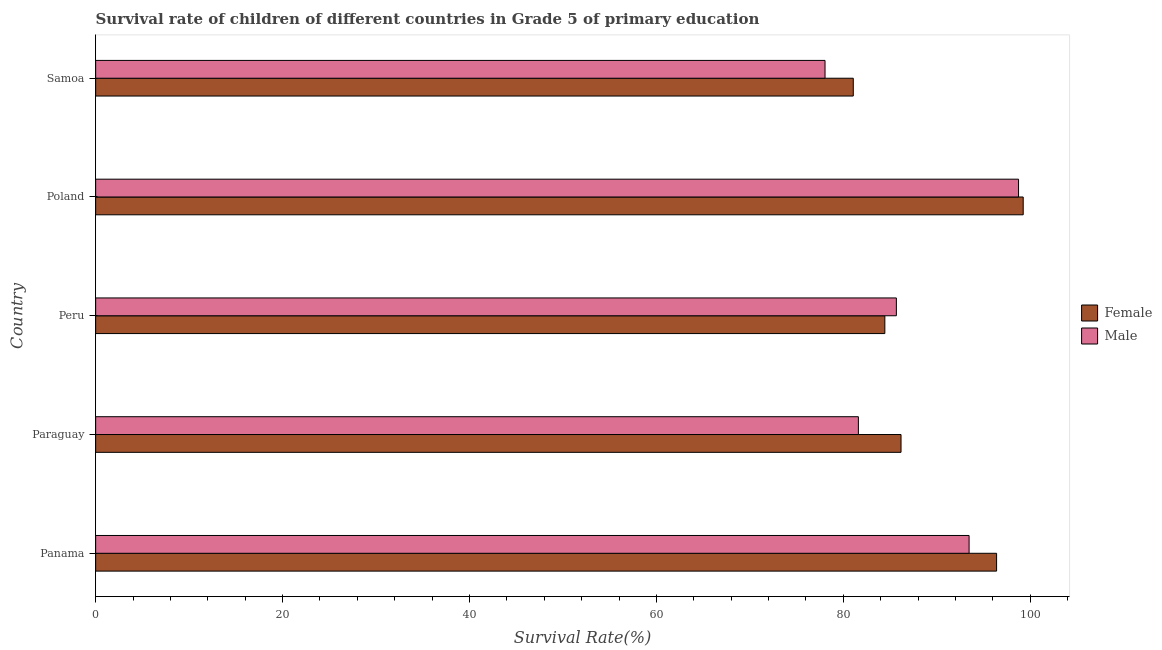How many groups of bars are there?
Ensure brevity in your answer.  5. Are the number of bars on each tick of the Y-axis equal?
Provide a short and direct response. Yes. What is the label of the 1st group of bars from the top?
Your answer should be compact. Samoa. In how many cases, is the number of bars for a given country not equal to the number of legend labels?
Your answer should be compact. 0. What is the survival rate of female students in primary education in Panama?
Keep it short and to the point. 96.4. Across all countries, what is the maximum survival rate of male students in primary education?
Your answer should be compact. 98.74. Across all countries, what is the minimum survival rate of female students in primary education?
Keep it short and to the point. 81.06. In which country was the survival rate of male students in primary education minimum?
Your response must be concise. Samoa. What is the total survival rate of female students in primary education in the graph?
Your answer should be compact. 447.31. What is the difference between the survival rate of female students in primary education in Paraguay and that in Peru?
Give a very brief answer. 1.73. What is the difference between the survival rate of female students in primary education in Paraguay and the survival rate of male students in primary education in Poland?
Your answer should be very brief. -12.57. What is the average survival rate of male students in primary education per country?
Provide a succinct answer. 87.5. What is the difference between the survival rate of male students in primary education and survival rate of female students in primary education in Paraguay?
Your answer should be compact. -4.56. In how many countries, is the survival rate of female students in primary education greater than 16 %?
Provide a short and direct response. 5. What is the ratio of the survival rate of female students in primary education in Peru to that in Poland?
Your response must be concise. 0.85. What is the difference between the highest and the second highest survival rate of male students in primary education?
Provide a short and direct response. 5.29. What is the difference between the highest and the lowest survival rate of male students in primary education?
Keep it short and to the point. 20.7. In how many countries, is the survival rate of female students in primary education greater than the average survival rate of female students in primary education taken over all countries?
Offer a terse response. 2. Is the sum of the survival rate of male students in primary education in Paraguay and Peru greater than the maximum survival rate of female students in primary education across all countries?
Offer a very short reply. Yes. What does the 2nd bar from the bottom in Panama represents?
Ensure brevity in your answer.  Male. How many bars are there?
Keep it short and to the point. 10. Are all the bars in the graph horizontal?
Make the answer very short. Yes. What is the difference between two consecutive major ticks on the X-axis?
Your response must be concise. 20. Does the graph contain any zero values?
Your answer should be compact. No. Does the graph contain grids?
Make the answer very short. No. How are the legend labels stacked?
Offer a terse response. Vertical. What is the title of the graph?
Your answer should be compact. Survival rate of children of different countries in Grade 5 of primary education. What is the label or title of the X-axis?
Offer a very short reply. Survival Rate(%). What is the Survival Rate(%) in Female in Panama?
Make the answer very short. 96.4. What is the Survival Rate(%) in Male in Panama?
Provide a short and direct response. 93.45. What is the Survival Rate(%) of Female in Paraguay?
Give a very brief answer. 86.17. What is the Survival Rate(%) of Male in Paraguay?
Provide a short and direct response. 81.61. What is the Survival Rate(%) in Female in Peru?
Give a very brief answer. 84.44. What is the Survival Rate(%) in Male in Peru?
Give a very brief answer. 85.67. What is the Survival Rate(%) of Female in Poland?
Your answer should be compact. 99.24. What is the Survival Rate(%) of Male in Poland?
Your answer should be compact. 98.74. What is the Survival Rate(%) in Female in Samoa?
Make the answer very short. 81.06. What is the Survival Rate(%) of Male in Samoa?
Provide a succinct answer. 78.04. Across all countries, what is the maximum Survival Rate(%) in Female?
Make the answer very short. 99.24. Across all countries, what is the maximum Survival Rate(%) of Male?
Your answer should be very brief. 98.74. Across all countries, what is the minimum Survival Rate(%) in Female?
Give a very brief answer. 81.06. Across all countries, what is the minimum Survival Rate(%) in Male?
Provide a succinct answer. 78.04. What is the total Survival Rate(%) in Female in the graph?
Provide a short and direct response. 447.31. What is the total Survival Rate(%) in Male in the graph?
Provide a succinct answer. 437.52. What is the difference between the Survival Rate(%) of Female in Panama and that in Paraguay?
Make the answer very short. 10.23. What is the difference between the Survival Rate(%) in Male in Panama and that in Paraguay?
Provide a succinct answer. 11.84. What is the difference between the Survival Rate(%) in Female in Panama and that in Peru?
Ensure brevity in your answer.  11.96. What is the difference between the Survival Rate(%) of Male in Panama and that in Peru?
Your answer should be compact. 7.78. What is the difference between the Survival Rate(%) in Female in Panama and that in Poland?
Offer a very short reply. -2.85. What is the difference between the Survival Rate(%) in Male in Panama and that in Poland?
Your response must be concise. -5.29. What is the difference between the Survival Rate(%) of Female in Panama and that in Samoa?
Ensure brevity in your answer.  15.33. What is the difference between the Survival Rate(%) of Male in Panama and that in Samoa?
Ensure brevity in your answer.  15.41. What is the difference between the Survival Rate(%) of Female in Paraguay and that in Peru?
Provide a succinct answer. 1.73. What is the difference between the Survival Rate(%) in Male in Paraguay and that in Peru?
Your answer should be very brief. -4.06. What is the difference between the Survival Rate(%) in Female in Paraguay and that in Poland?
Keep it short and to the point. -13.07. What is the difference between the Survival Rate(%) of Male in Paraguay and that in Poland?
Provide a succinct answer. -17.14. What is the difference between the Survival Rate(%) of Female in Paraguay and that in Samoa?
Your answer should be compact. 5.11. What is the difference between the Survival Rate(%) in Male in Paraguay and that in Samoa?
Make the answer very short. 3.57. What is the difference between the Survival Rate(%) in Female in Peru and that in Poland?
Ensure brevity in your answer.  -14.8. What is the difference between the Survival Rate(%) in Male in Peru and that in Poland?
Keep it short and to the point. -13.07. What is the difference between the Survival Rate(%) of Female in Peru and that in Samoa?
Your response must be concise. 3.38. What is the difference between the Survival Rate(%) in Male in Peru and that in Samoa?
Your answer should be very brief. 7.63. What is the difference between the Survival Rate(%) of Female in Poland and that in Samoa?
Your answer should be compact. 18.18. What is the difference between the Survival Rate(%) in Male in Poland and that in Samoa?
Ensure brevity in your answer.  20.7. What is the difference between the Survival Rate(%) in Female in Panama and the Survival Rate(%) in Male in Paraguay?
Provide a succinct answer. 14.79. What is the difference between the Survival Rate(%) in Female in Panama and the Survival Rate(%) in Male in Peru?
Your answer should be very brief. 10.72. What is the difference between the Survival Rate(%) of Female in Panama and the Survival Rate(%) of Male in Poland?
Provide a short and direct response. -2.35. What is the difference between the Survival Rate(%) of Female in Panama and the Survival Rate(%) of Male in Samoa?
Offer a terse response. 18.36. What is the difference between the Survival Rate(%) in Female in Paraguay and the Survival Rate(%) in Male in Peru?
Give a very brief answer. 0.5. What is the difference between the Survival Rate(%) of Female in Paraguay and the Survival Rate(%) of Male in Poland?
Ensure brevity in your answer.  -12.57. What is the difference between the Survival Rate(%) in Female in Paraguay and the Survival Rate(%) in Male in Samoa?
Provide a succinct answer. 8.13. What is the difference between the Survival Rate(%) in Female in Peru and the Survival Rate(%) in Male in Poland?
Offer a very short reply. -14.31. What is the difference between the Survival Rate(%) of Female in Peru and the Survival Rate(%) of Male in Samoa?
Provide a short and direct response. 6.4. What is the difference between the Survival Rate(%) in Female in Poland and the Survival Rate(%) in Male in Samoa?
Your response must be concise. 21.2. What is the average Survival Rate(%) in Female per country?
Ensure brevity in your answer.  89.46. What is the average Survival Rate(%) in Male per country?
Give a very brief answer. 87.5. What is the difference between the Survival Rate(%) in Female and Survival Rate(%) in Male in Panama?
Your response must be concise. 2.94. What is the difference between the Survival Rate(%) in Female and Survival Rate(%) in Male in Paraguay?
Make the answer very short. 4.56. What is the difference between the Survival Rate(%) in Female and Survival Rate(%) in Male in Peru?
Give a very brief answer. -1.23. What is the difference between the Survival Rate(%) in Female and Survival Rate(%) in Male in Poland?
Your response must be concise. 0.5. What is the difference between the Survival Rate(%) in Female and Survival Rate(%) in Male in Samoa?
Keep it short and to the point. 3.02. What is the ratio of the Survival Rate(%) in Female in Panama to that in Paraguay?
Keep it short and to the point. 1.12. What is the ratio of the Survival Rate(%) in Male in Panama to that in Paraguay?
Keep it short and to the point. 1.15. What is the ratio of the Survival Rate(%) in Female in Panama to that in Peru?
Offer a terse response. 1.14. What is the ratio of the Survival Rate(%) in Male in Panama to that in Peru?
Give a very brief answer. 1.09. What is the ratio of the Survival Rate(%) of Female in Panama to that in Poland?
Ensure brevity in your answer.  0.97. What is the ratio of the Survival Rate(%) of Male in Panama to that in Poland?
Keep it short and to the point. 0.95. What is the ratio of the Survival Rate(%) of Female in Panama to that in Samoa?
Offer a very short reply. 1.19. What is the ratio of the Survival Rate(%) in Male in Panama to that in Samoa?
Your response must be concise. 1.2. What is the ratio of the Survival Rate(%) in Female in Paraguay to that in Peru?
Offer a terse response. 1.02. What is the ratio of the Survival Rate(%) of Male in Paraguay to that in Peru?
Offer a terse response. 0.95. What is the ratio of the Survival Rate(%) in Female in Paraguay to that in Poland?
Your response must be concise. 0.87. What is the ratio of the Survival Rate(%) of Male in Paraguay to that in Poland?
Give a very brief answer. 0.83. What is the ratio of the Survival Rate(%) of Female in Paraguay to that in Samoa?
Provide a short and direct response. 1.06. What is the ratio of the Survival Rate(%) of Male in Paraguay to that in Samoa?
Offer a terse response. 1.05. What is the ratio of the Survival Rate(%) in Female in Peru to that in Poland?
Provide a short and direct response. 0.85. What is the ratio of the Survival Rate(%) in Male in Peru to that in Poland?
Provide a short and direct response. 0.87. What is the ratio of the Survival Rate(%) of Female in Peru to that in Samoa?
Provide a short and direct response. 1.04. What is the ratio of the Survival Rate(%) of Male in Peru to that in Samoa?
Ensure brevity in your answer.  1.1. What is the ratio of the Survival Rate(%) of Female in Poland to that in Samoa?
Ensure brevity in your answer.  1.22. What is the ratio of the Survival Rate(%) of Male in Poland to that in Samoa?
Your answer should be compact. 1.27. What is the difference between the highest and the second highest Survival Rate(%) of Female?
Your answer should be very brief. 2.85. What is the difference between the highest and the second highest Survival Rate(%) in Male?
Offer a terse response. 5.29. What is the difference between the highest and the lowest Survival Rate(%) of Female?
Your response must be concise. 18.18. What is the difference between the highest and the lowest Survival Rate(%) in Male?
Offer a very short reply. 20.7. 